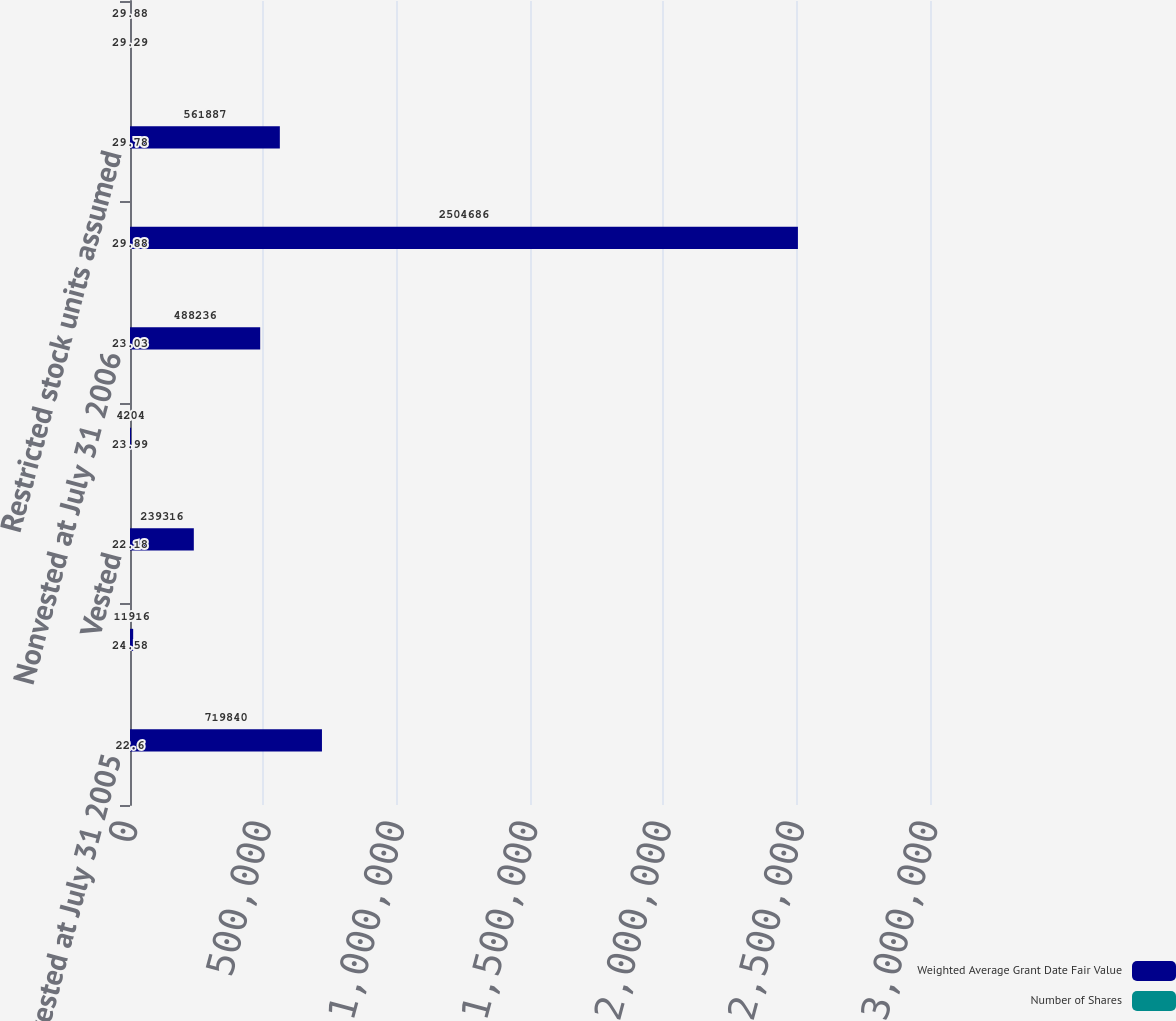Convert chart. <chart><loc_0><loc_0><loc_500><loc_500><stacked_bar_chart><ecel><fcel>Nonvested at July 31 2005<fcel>Granted<fcel>Vested<fcel>Forfeited<fcel>Nonvested at July 31 2006<fcel>Nonvested at July 31 2007<fcel>Restricted stock units assumed<fcel>Nonvested at July 31 2008<nl><fcel>Weighted Average Grant Date Fair Value<fcel>719840<fcel>11916<fcel>239316<fcel>4204<fcel>488236<fcel>2.50469e+06<fcel>561887<fcel>29.88<nl><fcel>Number of Shares<fcel>22.6<fcel>24.58<fcel>22.18<fcel>23.99<fcel>23.03<fcel>29.88<fcel>29.78<fcel>29.29<nl></chart> 